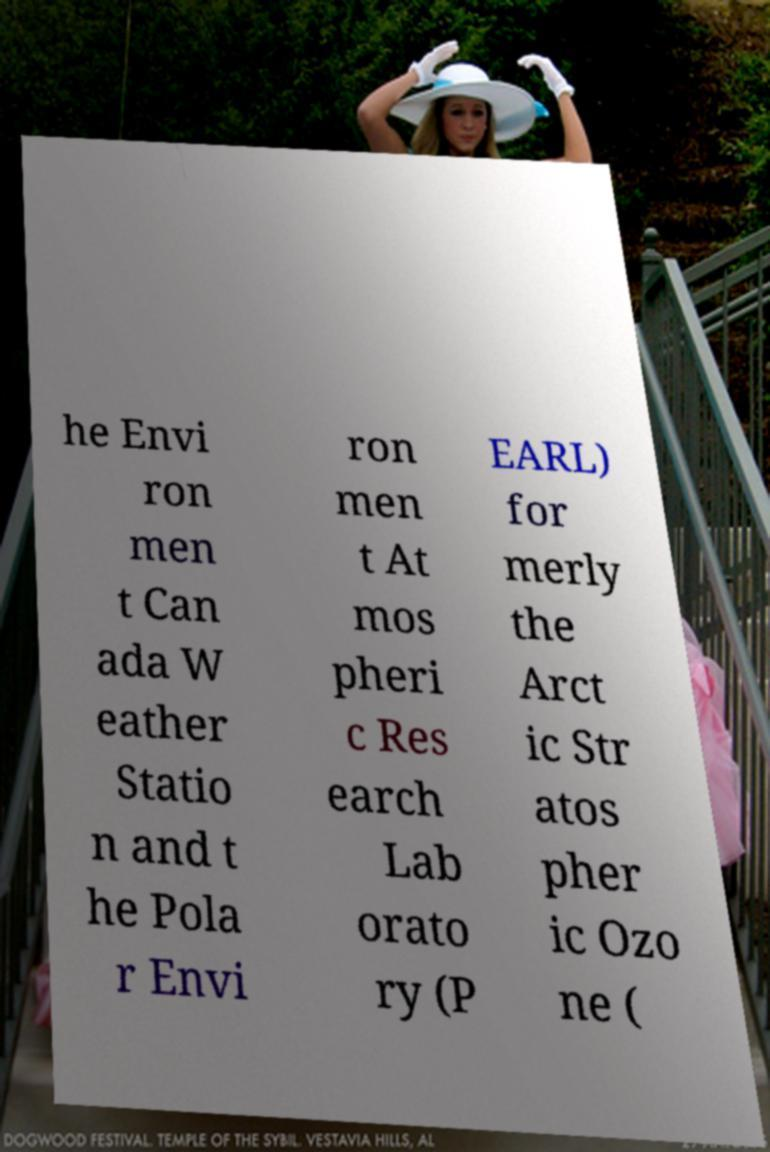Please identify and transcribe the text found in this image. he Envi ron men t Can ada W eather Statio n and t he Pola r Envi ron men t At mos pheri c Res earch Lab orato ry (P EARL) for merly the Arct ic Str atos pher ic Ozo ne ( 